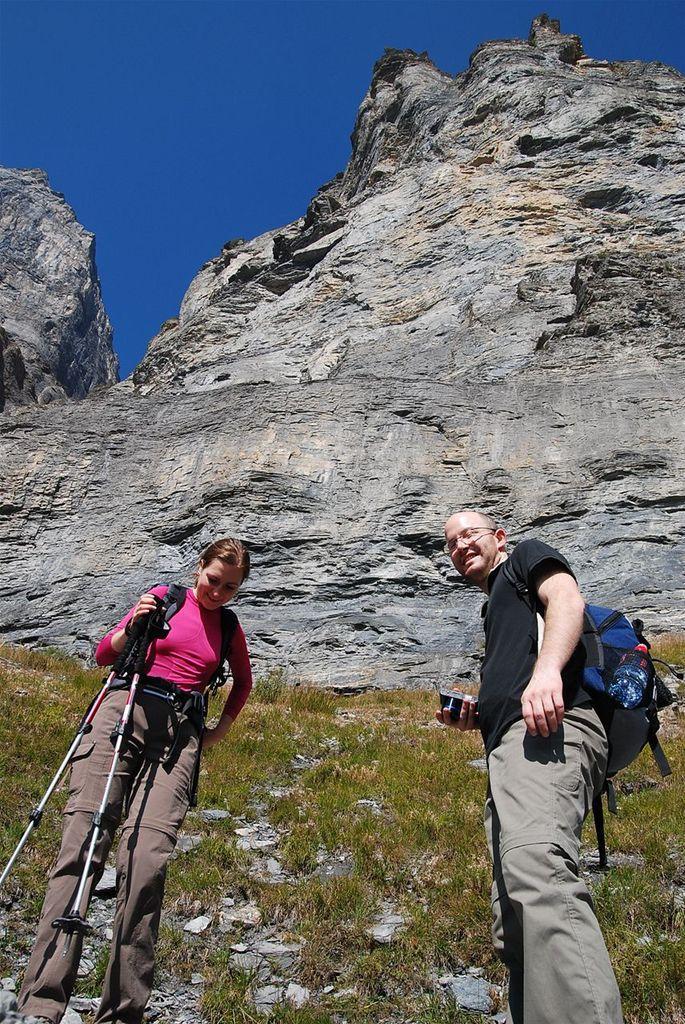Could you give a brief overview of what you see in this image? In this picture there are two people standing and smiling, among them there is a man holding an object and carrying a bag and there is a woman holding sticks. We can see grass, stones and cliffs. In the background of the image we can see the sky in blue color. 